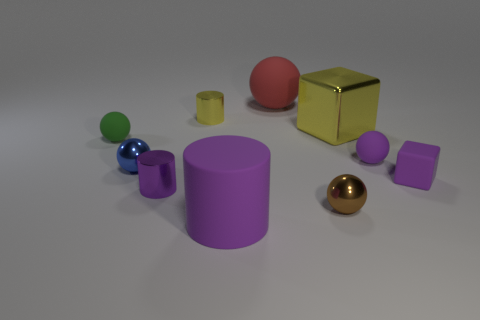Subtract all red spheres. How many spheres are left? 4 Subtract all purple rubber balls. How many balls are left? 4 Subtract all yellow spheres. Subtract all yellow cylinders. How many spheres are left? 5 Subtract all blocks. How many objects are left? 8 Subtract all big red matte spheres. Subtract all large purple matte objects. How many objects are left? 8 Add 4 big rubber cylinders. How many big rubber cylinders are left? 5 Add 5 metallic objects. How many metallic objects exist? 10 Subtract 1 yellow blocks. How many objects are left? 9 